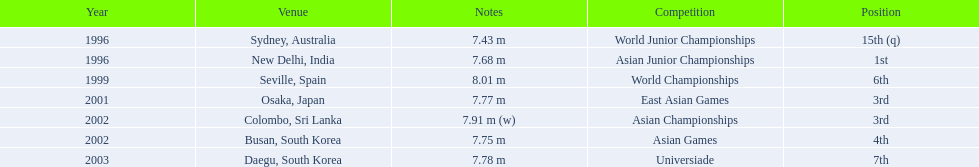What jumps did huang le make in 2002? 7.91 m (w), 7.75 m. Which jump was the longest? 7.91 m (w). 